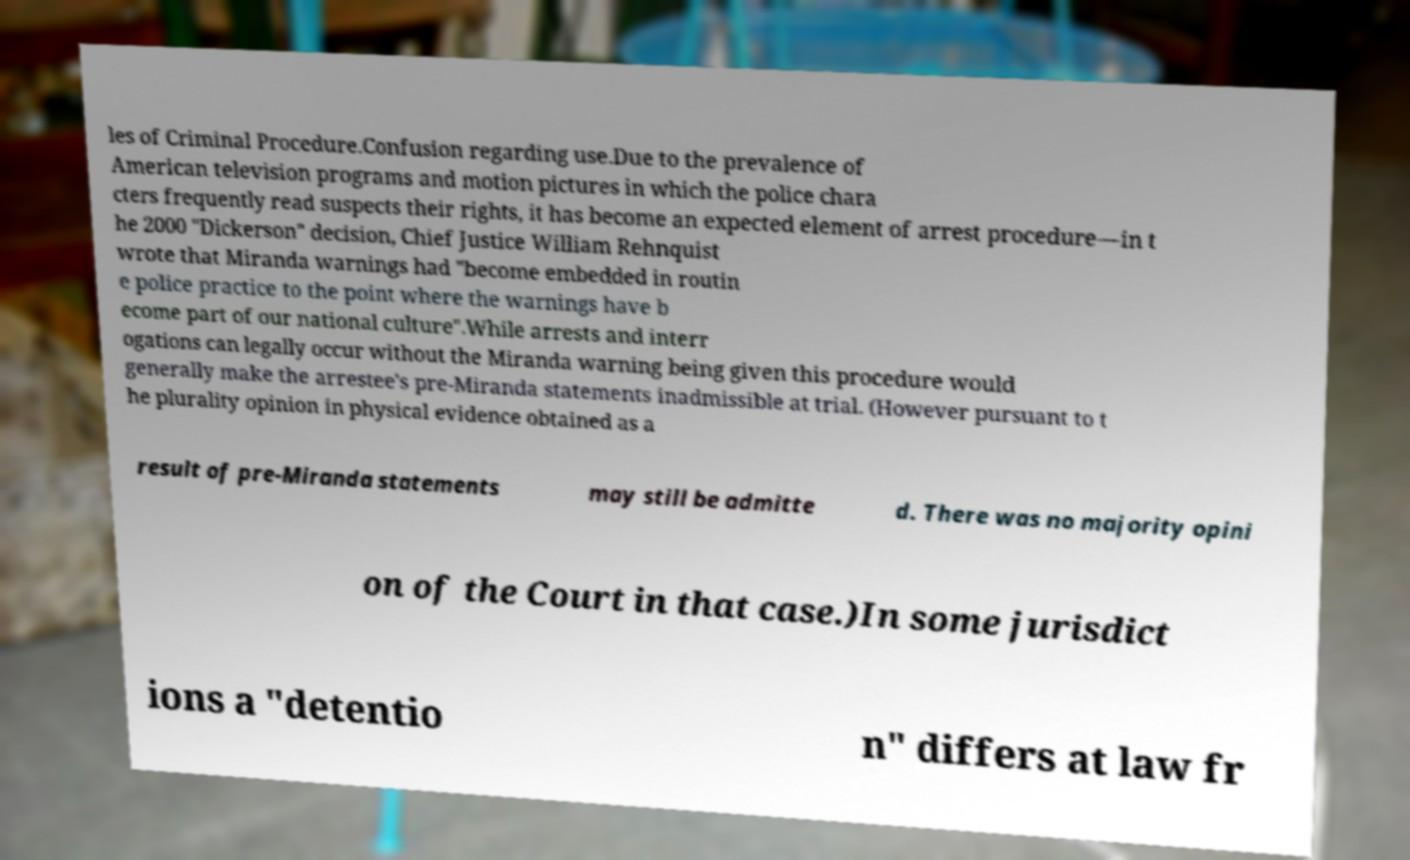Could you extract and type out the text from this image? les of Criminal Procedure.Confusion regarding use.Due to the prevalence of American television programs and motion pictures in which the police chara cters frequently read suspects their rights, it has become an expected element of arrest procedure—in t he 2000 "Dickerson" decision, Chief Justice William Rehnquist wrote that Miranda warnings had "become embedded in routin e police practice to the point where the warnings have b ecome part of our national culture".While arrests and interr ogations can legally occur without the Miranda warning being given this procedure would generally make the arrestee's pre-Miranda statements inadmissible at trial. (However pursuant to t he plurality opinion in physical evidence obtained as a result of pre-Miranda statements may still be admitte d. There was no majority opini on of the Court in that case.)In some jurisdict ions a "detentio n" differs at law fr 